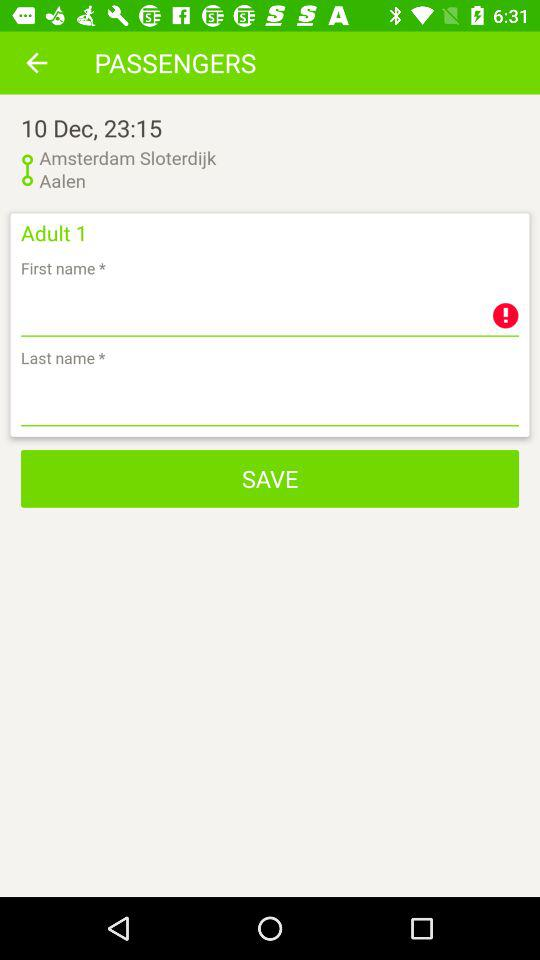How many passengers are in this booking?
Answer the question using a single word or phrase. 1 